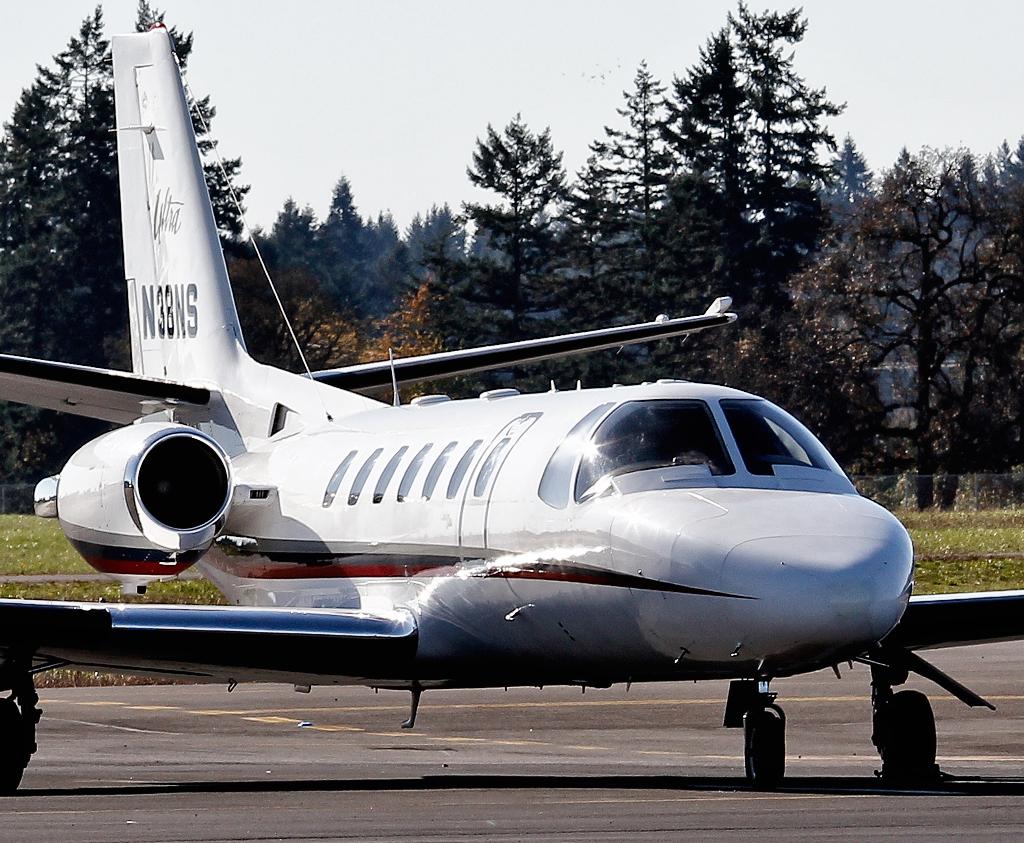What is this planes number?
Keep it short and to the point. N38ns. What's this aircraft's code?
Keep it short and to the point. N38ns. 